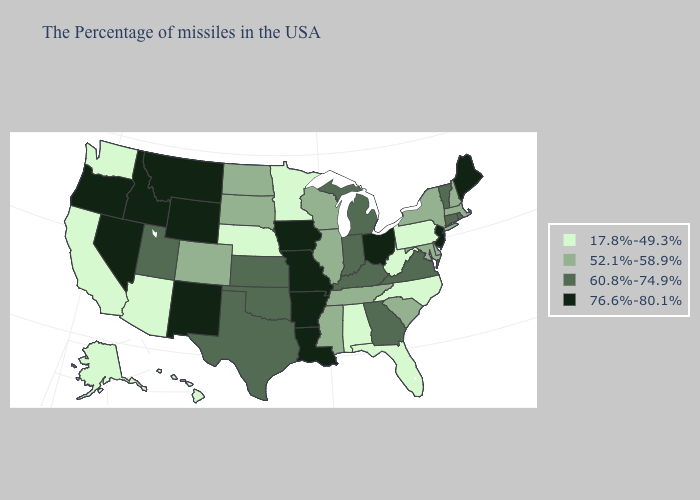What is the value of Connecticut?
Concise answer only. 60.8%-74.9%. Which states have the lowest value in the MidWest?
Answer briefly. Minnesota, Nebraska. What is the highest value in states that border Tennessee?
Write a very short answer. 76.6%-80.1%. Which states have the lowest value in the South?
Be succinct. North Carolina, West Virginia, Florida, Alabama. Is the legend a continuous bar?
Give a very brief answer. No. What is the lowest value in the West?
Short answer required. 17.8%-49.3%. Does the first symbol in the legend represent the smallest category?
Keep it brief. Yes. What is the highest value in the South ?
Short answer required. 76.6%-80.1%. Name the states that have a value in the range 17.8%-49.3%?
Keep it brief. Pennsylvania, North Carolina, West Virginia, Florida, Alabama, Minnesota, Nebraska, Arizona, California, Washington, Alaska, Hawaii. What is the lowest value in the USA?
Concise answer only. 17.8%-49.3%. Name the states that have a value in the range 52.1%-58.9%?
Be succinct. Massachusetts, New Hampshire, New York, Delaware, Maryland, South Carolina, Tennessee, Wisconsin, Illinois, Mississippi, South Dakota, North Dakota, Colorado. What is the value of Connecticut?
Answer briefly. 60.8%-74.9%. Among the states that border Louisiana , which have the lowest value?
Give a very brief answer. Mississippi. Which states have the highest value in the USA?
Answer briefly. Maine, New Jersey, Ohio, Louisiana, Missouri, Arkansas, Iowa, Wyoming, New Mexico, Montana, Idaho, Nevada, Oregon. How many symbols are there in the legend?
Concise answer only. 4. 